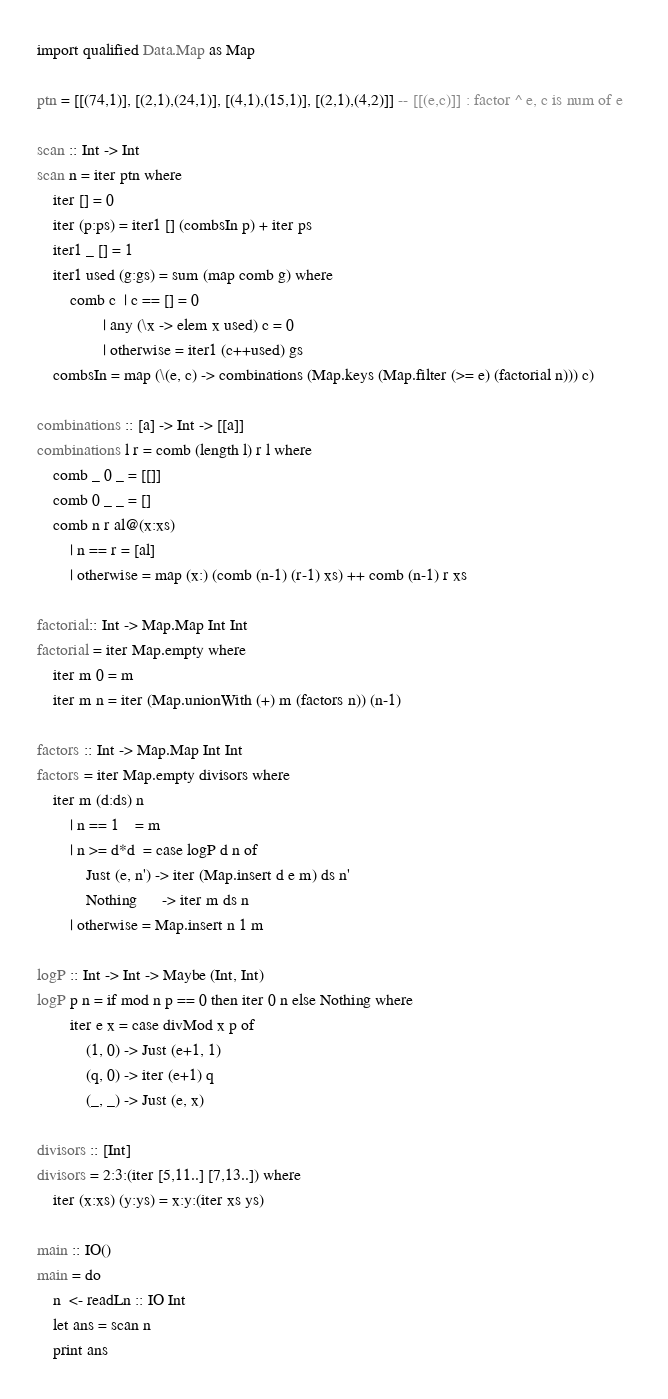Convert code to text. <code><loc_0><loc_0><loc_500><loc_500><_Haskell_>import qualified Data.Map as Map

ptn = [[(74,1)], [(2,1),(24,1)], [(4,1),(15,1)], [(2,1),(4,2)]] -- [[(e,c)]] : factor ^ e, c is num of e  

scan :: Int -> Int
scan n = iter ptn where
    iter [] = 0
    iter (p:ps) = iter1 [] (combsIn p) + iter ps
    iter1 _ [] = 1
    iter1 used (g:gs) = sum (map comb g) where
        comb c  | c == [] = 0
                | any (\x -> elem x used) c = 0
                | otherwise = iter1 (c++used) gs
    combsIn = map (\(e, c) -> combinations (Map.keys (Map.filter (>= e) (factorial n))) c)

combinations :: [a] -> Int -> [[a]]
combinations l r = comb (length l) r l where
    comb _ 0 _ = [[]]
    comb 0 _ _ = []
    comb n r al@(x:xs) 
        | n == r = [al]
        | otherwise = map (x:) (comb (n-1) (r-1) xs) ++ comb (n-1) r xs

factorial:: Int -> Map.Map Int Int
factorial = iter Map.empty where
    iter m 0 = m
    iter m n = iter (Map.unionWith (+) m (factors n)) (n-1)

factors :: Int -> Map.Map Int Int
factors = iter Map.empty divisors where
    iter m (d:ds) n
        | n == 1    = m
        | n >= d*d  = case logP d n of
            Just (e, n') -> iter (Map.insert d e m) ds n'
            Nothing      -> iter m ds n          
        | otherwise = Map.insert n 1 m 

logP :: Int -> Int -> Maybe (Int, Int)
logP p n = if mod n p == 0 then iter 0 n else Nothing where
        iter e x = case divMod x p of
            (1, 0) -> Just (e+1, 1)
            (q, 0) -> iter (e+1) q
            (_, _) -> Just (e, x)

divisors :: [Int]
divisors = 2:3:(iter [5,11..] [7,13..]) where
    iter (x:xs) (y:ys) = x:y:(iter xs ys)

main :: IO() 
main = do
    n  <- readLn :: IO Int
    let ans = scan n
    print ans</code> 